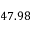Convert formula to latex. <formula><loc_0><loc_0><loc_500><loc_500>4 7 . 9 8</formula> 